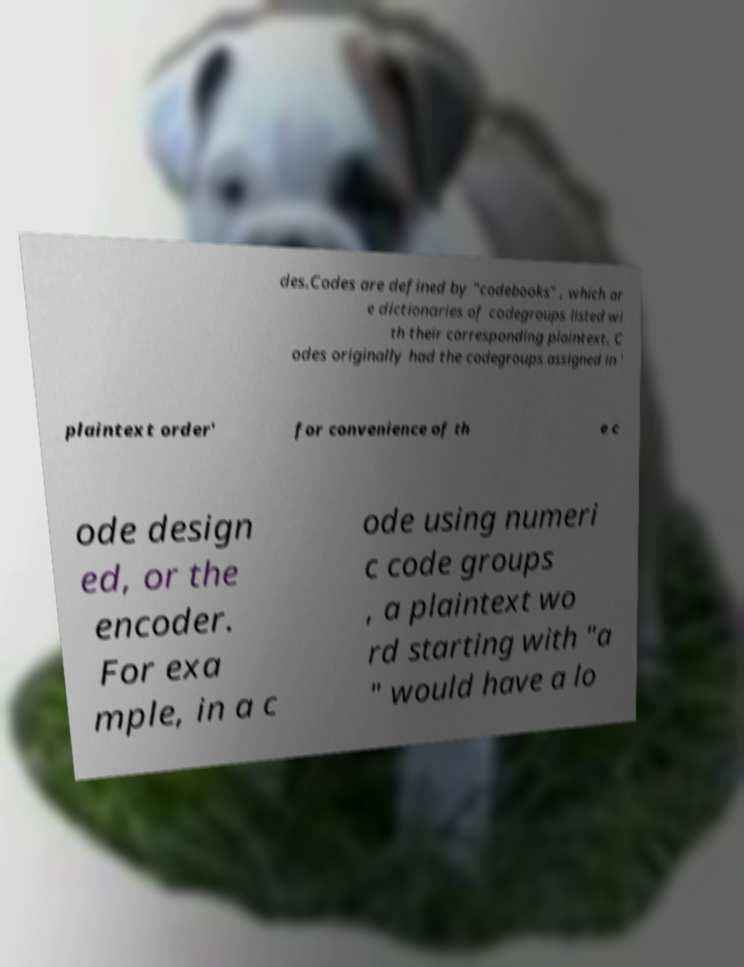There's text embedded in this image that I need extracted. Can you transcribe it verbatim? des.Codes are defined by "codebooks" , which ar e dictionaries of codegroups listed wi th their corresponding plaintext. C odes originally had the codegroups assigned in ' plaintext order' for convenience of th e c ode design ed, or the encoder. For exa mple, in a c ode using numeri c code groups , a plaintext wo rd starting with "a " would have a lo 